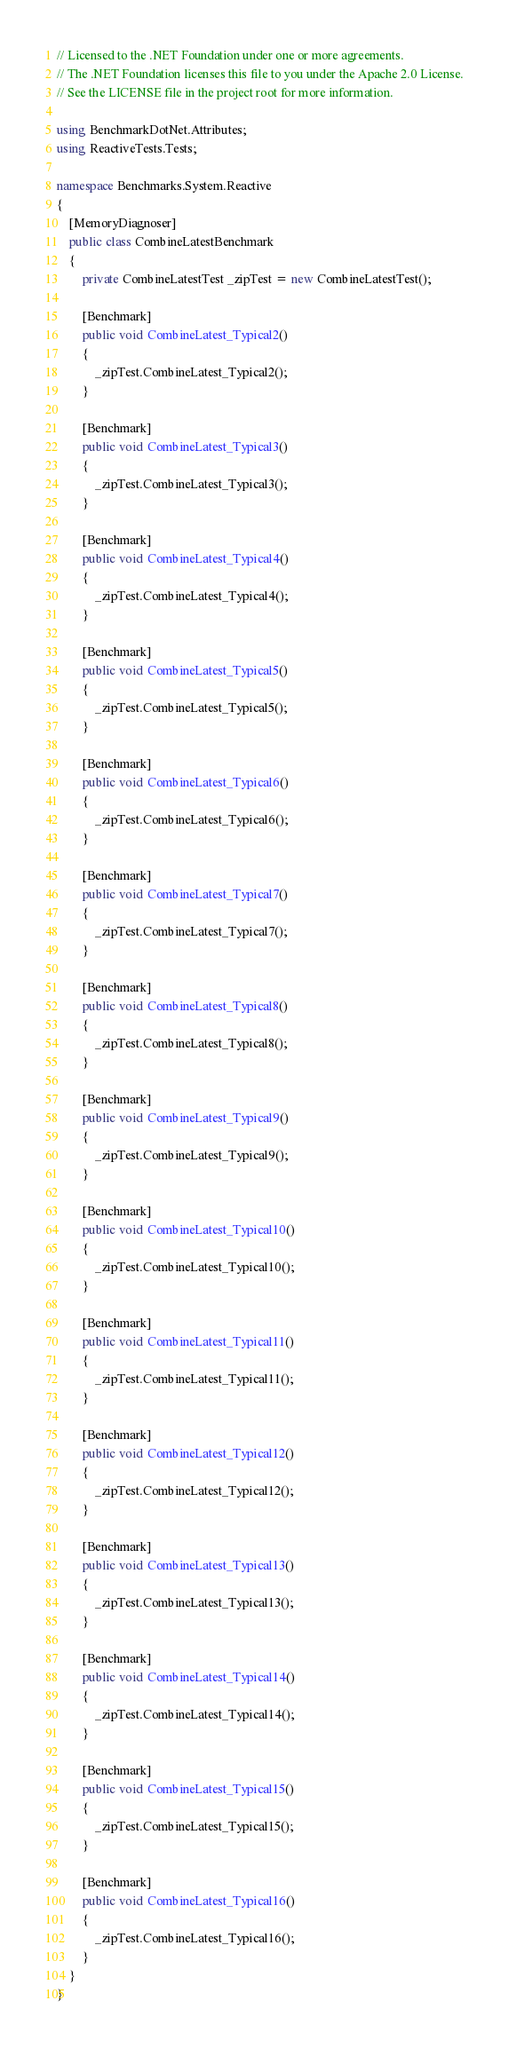<code> <loc_0><loc_0><loc_500><loc_500><_C#_>// Licensed to the .NET Foundation under one or more agreements.
// The .NET Foundation licenses this file to you under the Apache 2.0 License.
// See the LICENSE file in the project root for more information.

using BenchmarkDotNet.Attributes;
using ReactiveTests.Tests;

namespace Benchmarks.System.Reactive
{
    [MemoryDiagnoser]
    public class CombineLatestBenchmark
    {
        private CombineLatestTest _zipTest = new CombineLatestTest();

        [Benchmark]
        public void CombineLatest_Typical2()
        {
            _zipTest.CombineLatest_Typical2();
        }

        [Benchmark]
        public void CombineLatest_Typical3()
        {
            _zipTest.CombineLatest_Typical3();
        }

        [Benchmark]
        public void CombineLatest_Typical4()
        {
            _zipTest.CombineLatest_Typical4();
        }

        [Benchmark]
        public void CombineLatest_Typical5()
        {
            _zipTest.CombineLatest_Typical5();
        }

        [Benchmark]
        public void CombineLatest_Typical6()
        {
            _zipTest.CombineLatest_Typical6();
        }

        [Benchmark]
        public void CombineLatest_Typical7()
        {
            _zipTest.CombineLatest_Typical7();
        }

        [Benchmark]
        public void CombineLatest_Typical8()
        {
            _zipTest.CombineLatest_Typical8();
        }

        [Benchmark]
        public void CombineLatest_Typical9()
        {
            _zipTest.CombineLatest_Typical9();
        }

        [Benchmark]
        public void CombineLatest_Typical10()
        {
            _zipTest.CombineLatest_Typical10();
        }

        [Benchmark]
        public void CombineLatest_Typical11()
        {
            _zipTest.CombineLatest_Typical11();
        }

        [Benchmark]
        public void CombineLatest_Typical12()
        {
            _zipTest.CombineLatest_Typical12();
        }
        
        [Benchmark]
        public void CombineLatest_Typical13()
        {
            _zipTest.CombineLatest_Typical13();
        }

        [Benchmark]
        public void CombineLatest_Typical14()
        {
            _zipTest.CombineLatest_Typical14();
        }

        [Benchmark]
        public void CombineLatest_Typical15()
        {
            _zipTest.CombineLatest_Typical15();
        }

        [Benchmark]
        public void CombineLatest_Typical16()
        {
            _zipTest.CombineLatest_Typical16();
        }
    }
}
</code> 